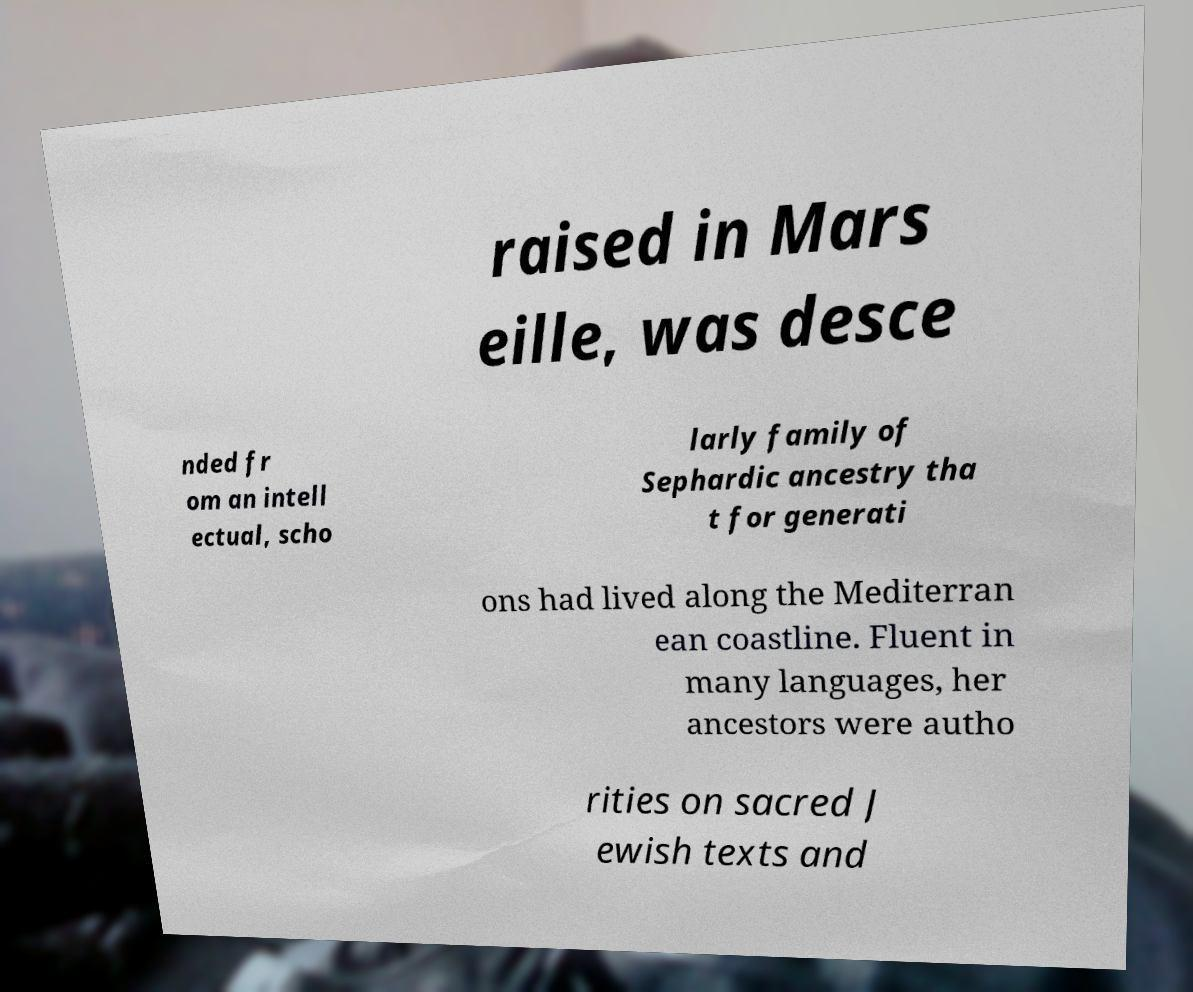Please read and relay the text visible in this image. What does it say? raised in Mars eille, was desce nded fr om an intell ectual, scho larly family of Sephardic ancestry tha t for generati ons had lived along the Mediterran ean coastline. Fluent in many languages, her ancestors were autho rities on sacred J ewish texts and 